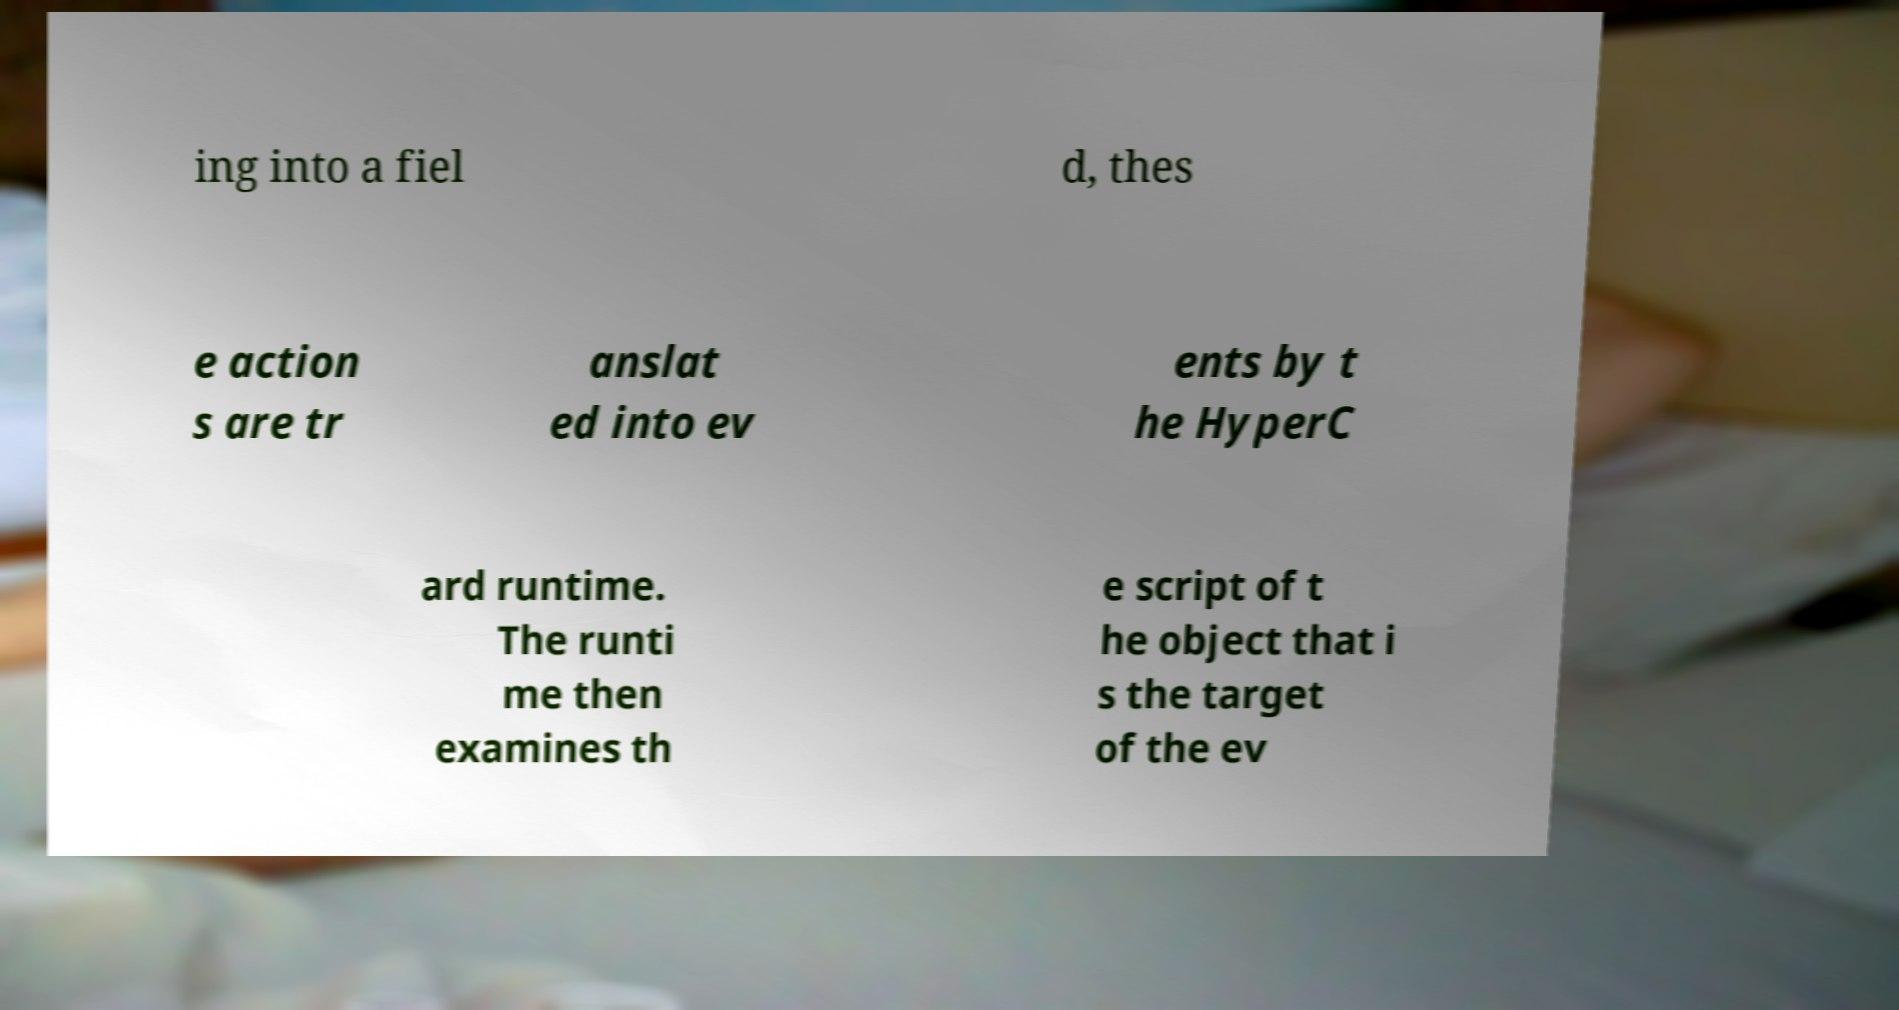There's text embedded in this image that I need extracted. Can you transcribe it verbatim? ing into a fiel d, thes e action s are tr anslat ed into ev ents by t he HyperC ard runtime. The runti me then examines th e script of t he object that i s the target of the ev 